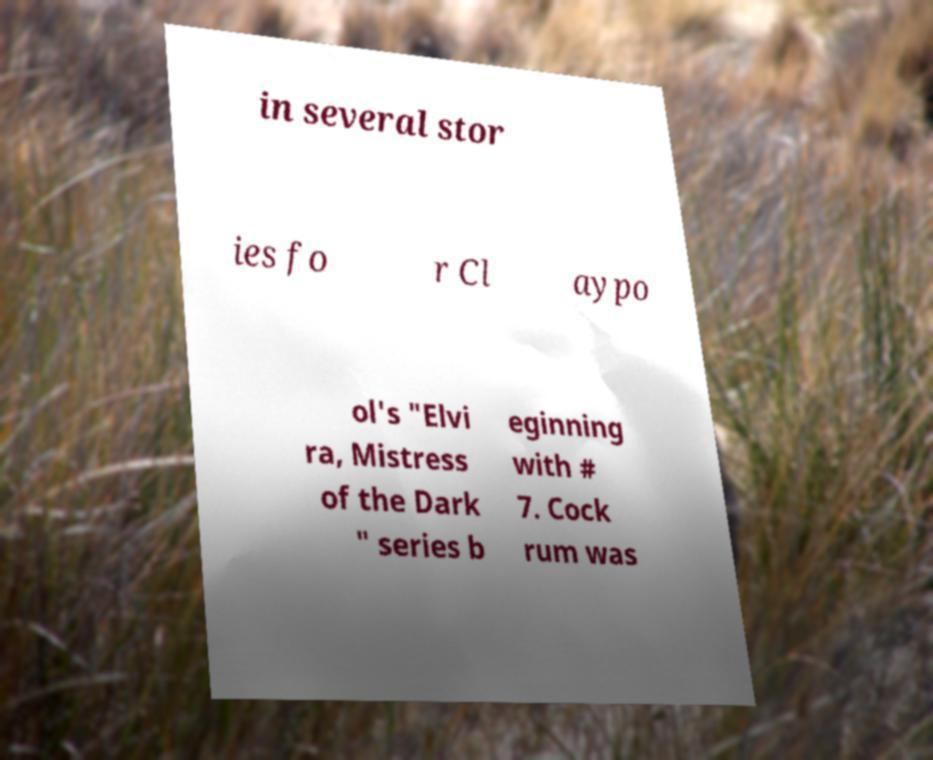What messages or text are displayed in this image? I need them in a readable, typed format. in several stor ies fo r Cl aypo ol's "Elvi ra, Mistress of the Dark " series b eginning with # 7. Cock rum was 